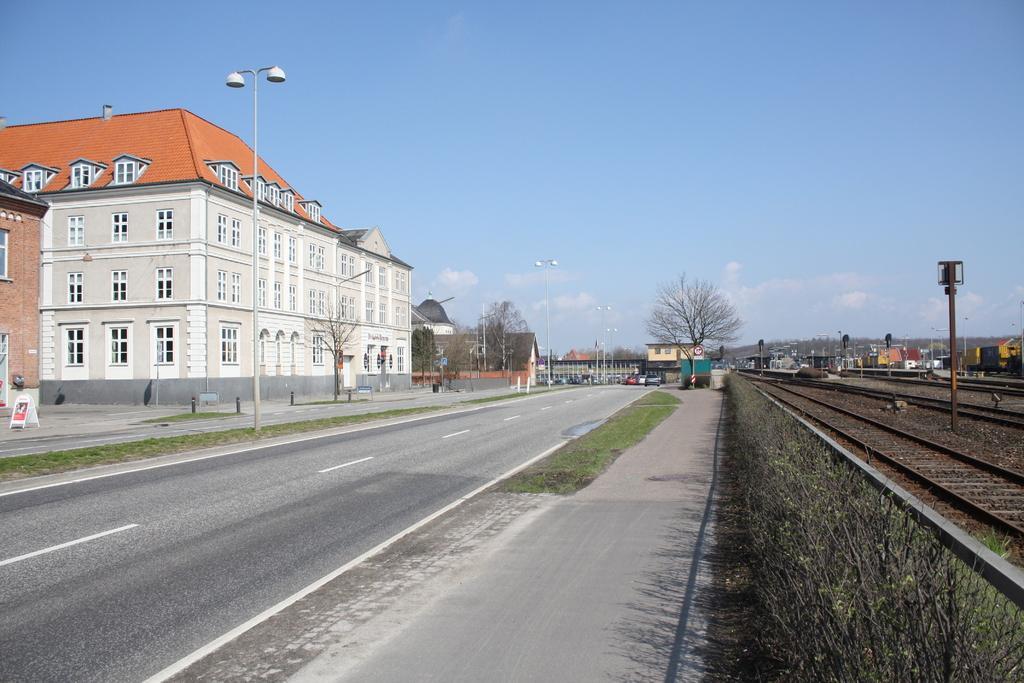Could you give a brief overview of what you see in this image? In the center of the image there are vehicles on the road. There are street lights. On the right side of the image there are plants. There is a railway track. There are poles. In the background of the image there are buildings, trees and sky. 